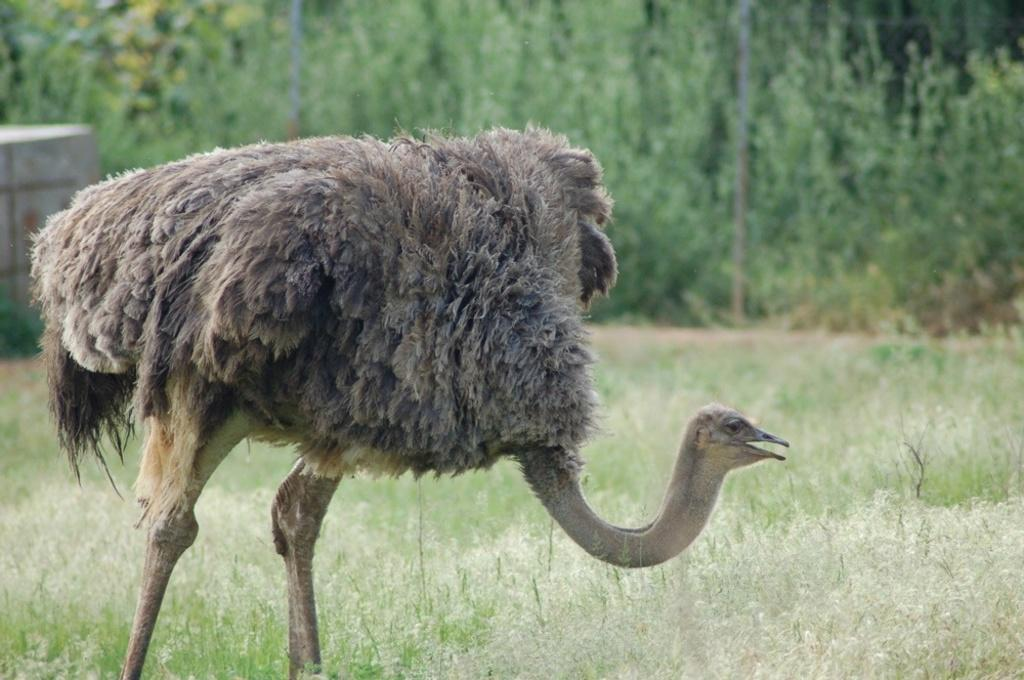What animal is present in the image? There is an ostrich in the image. Where is the ostrich located? The ostrich is standing in the grass. What type of vegetation can be seen in the image? There are trees in the image. What structures are present in the image? There are poles and a wall on the left side of the image. What is the ostrich's income in the image? Ostriches do not have an income, as they are animals and not people. 